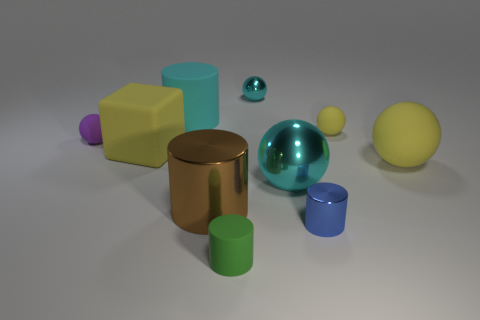What is the shape of the big thing that is the same color as the large rubber sphere?
Offer a terse response. Cube. The other shiny object that is the same shape as the big cyan metal object is what color?
Your answer should be compact. Cyan. What is the size of the cyan cylinder?
Provide a short and direct response. Large. Is the number of tiny yellow balls that are behind the large yellow rubber ball less than the number of yellow cylinders?
Offer a very short reply. No. Does the big yellow block have the same material as the purple object behind the big brown shiny cylinder?
Keep it short and to the point. Yes. Is there a large cyan shiny ball that is in front of the big object that is behind the small thing left of the large matte block?
Make the answer very short. Yes. What color is the tiny cylinder that is made of the same material as the big brown cylinder?
Your answer should be very brief. Blue. There is a sphere that is both on the left side of the large cyan ball and behind the tiny purple sphere; what size is it?
Provide a short and direct response. Small. Are there fewer tiny yellow balls left of the cyan cylinder than big matte things to the left of the big cyan metallic sphere?
Provide a succinct answer. Yes. Do the blue cylinder in front of the big cyan shiny sphere and the big yellow object to the left of the small yellow matte object have the same material?
Your answer should be compact. No. 